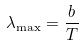Convert formula to latex. <formula><loc_0><loc_0><loc_500><loc_500>\lambda _ { \max } = \frac { b } { T }</formula> 